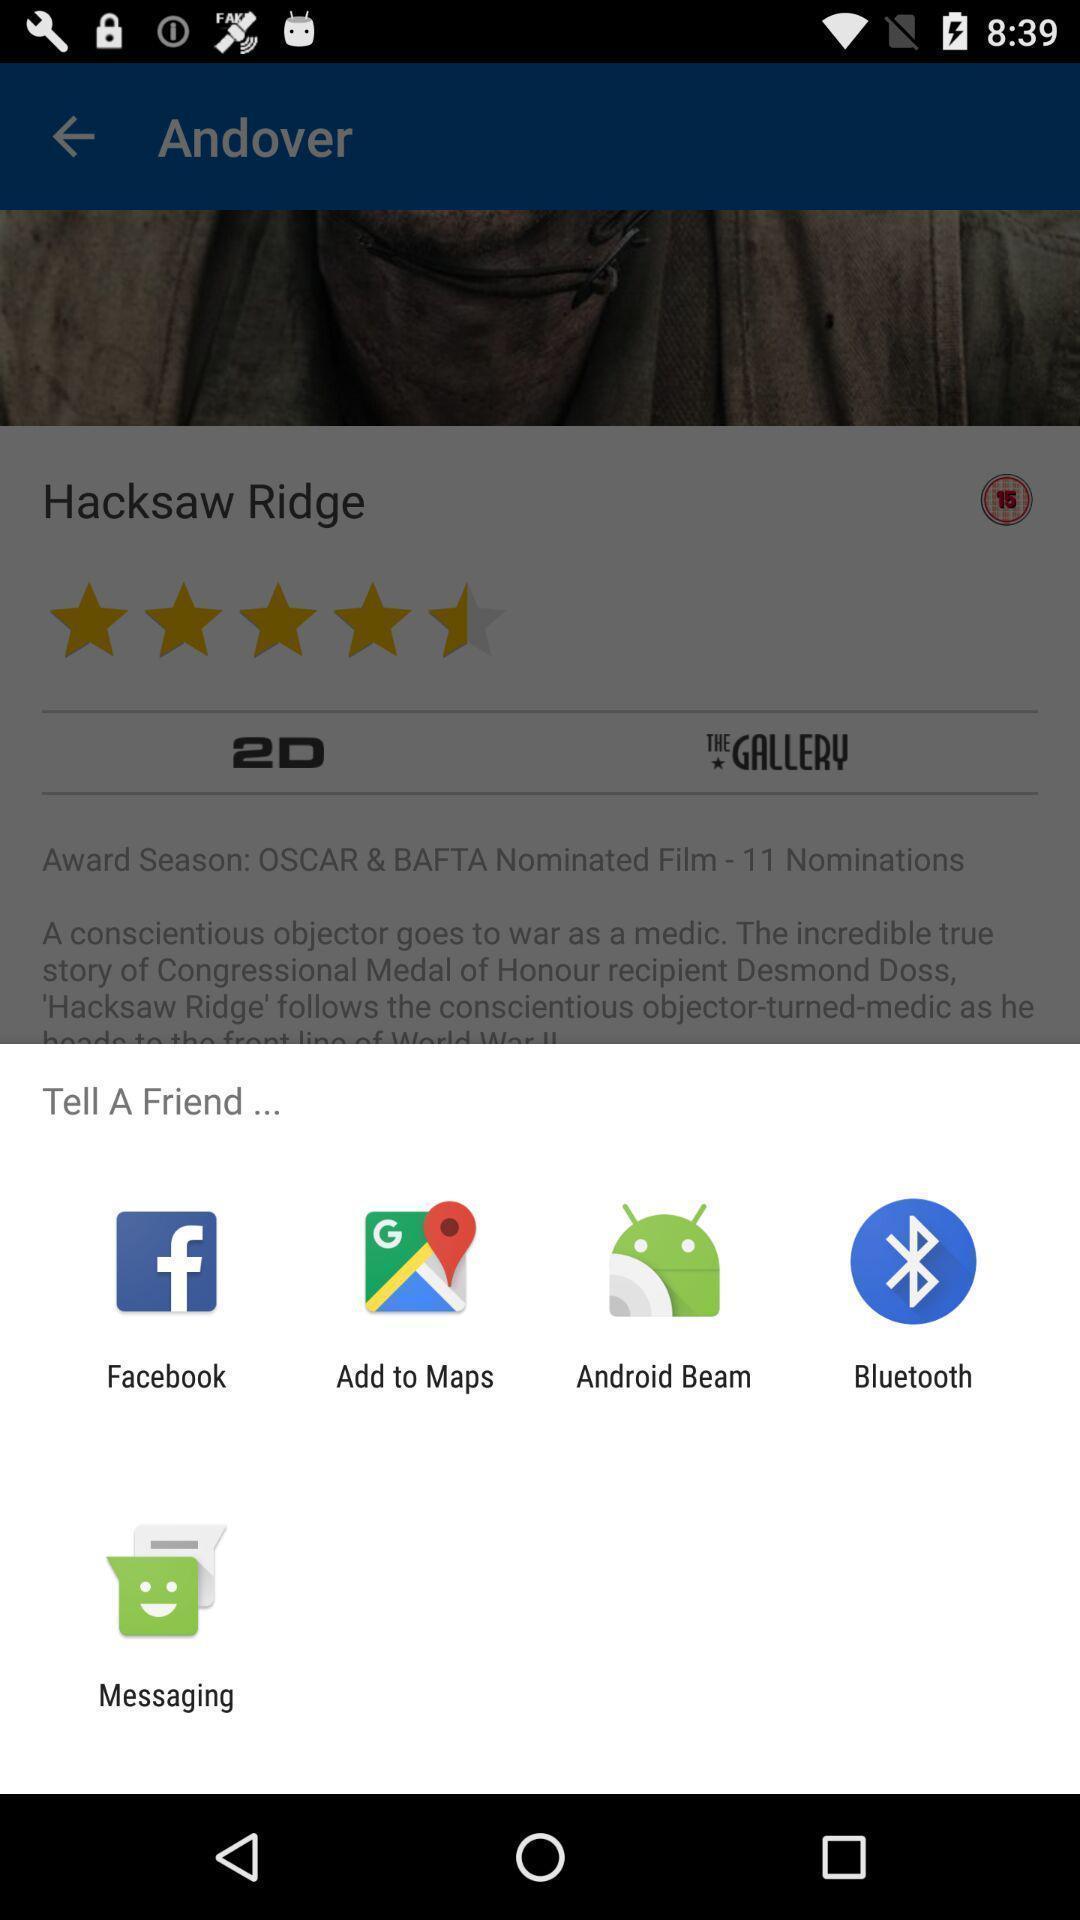Describe the key features of this screenshot. Popup to share for the movie app. 